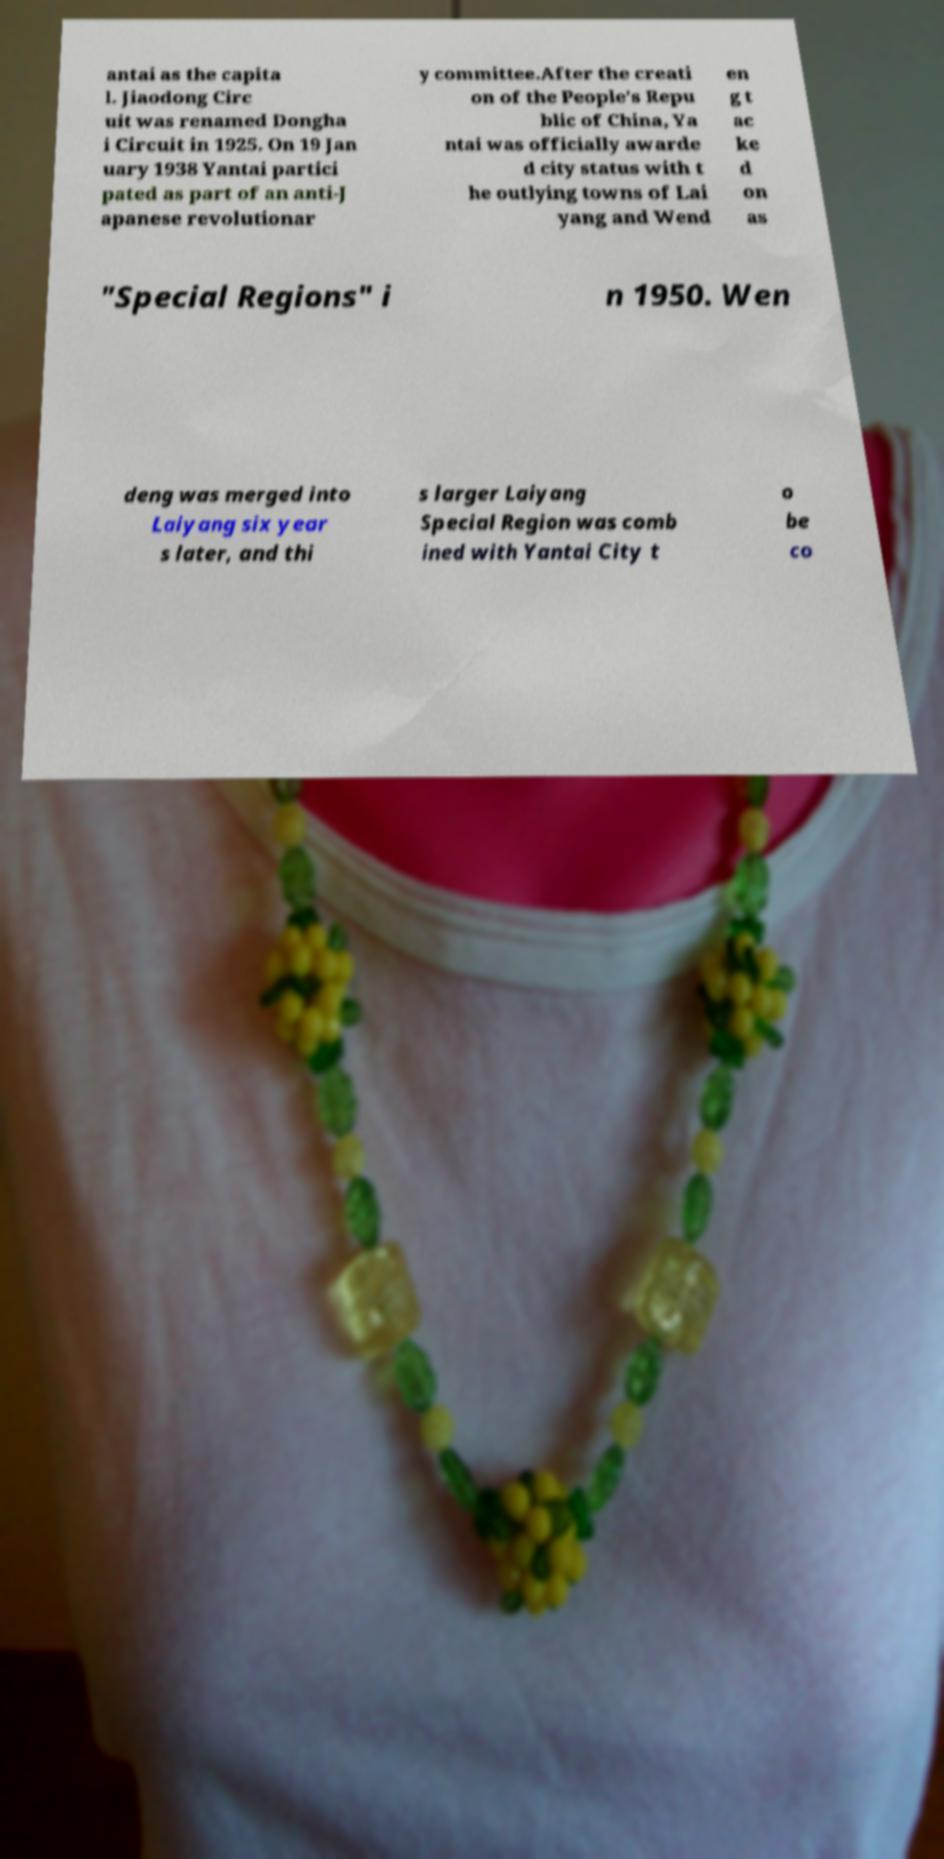Can you accurately transcribe the text from the provided image for me? antai as the capita l. Jiaodong Circ uit was renamed Dongha i Circuit in 1925. On 19 Jan uary 1938 Yantai partici pated as part of an anti-J apanese revolutionar y committee.After the creati on of the People's Repu blic of China, Ya ntai was officially awarde d city status with t he outlying towns of Lai yang and Wend en g t ac ke d on as "Special Regions" i n 1950. Wen deng was merged into Laiyang six year s later, and thi s larger Laiyang Special Region was comb ined with Yantai City t o be co 